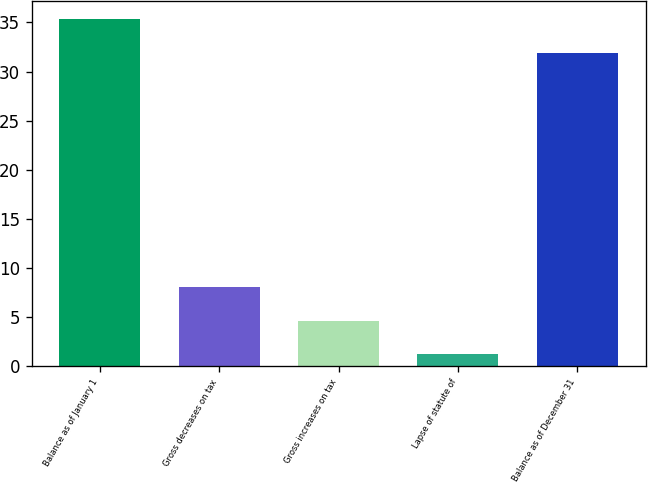Convert chart to OTSL. <chart><loc_0><loc_0><loc_500><loc_500><bar_chart><fcel>Balance as of January 1<fcel>Gross decreases on tax<fcel>Gross increases on tax<fcel>Lapse of statute of<fcel>Balance as of December 31<nl><fcel>35.4<fcel>8.04<fcel>4.62<fcel>1.2<fcel>31.9<nl></chart> 